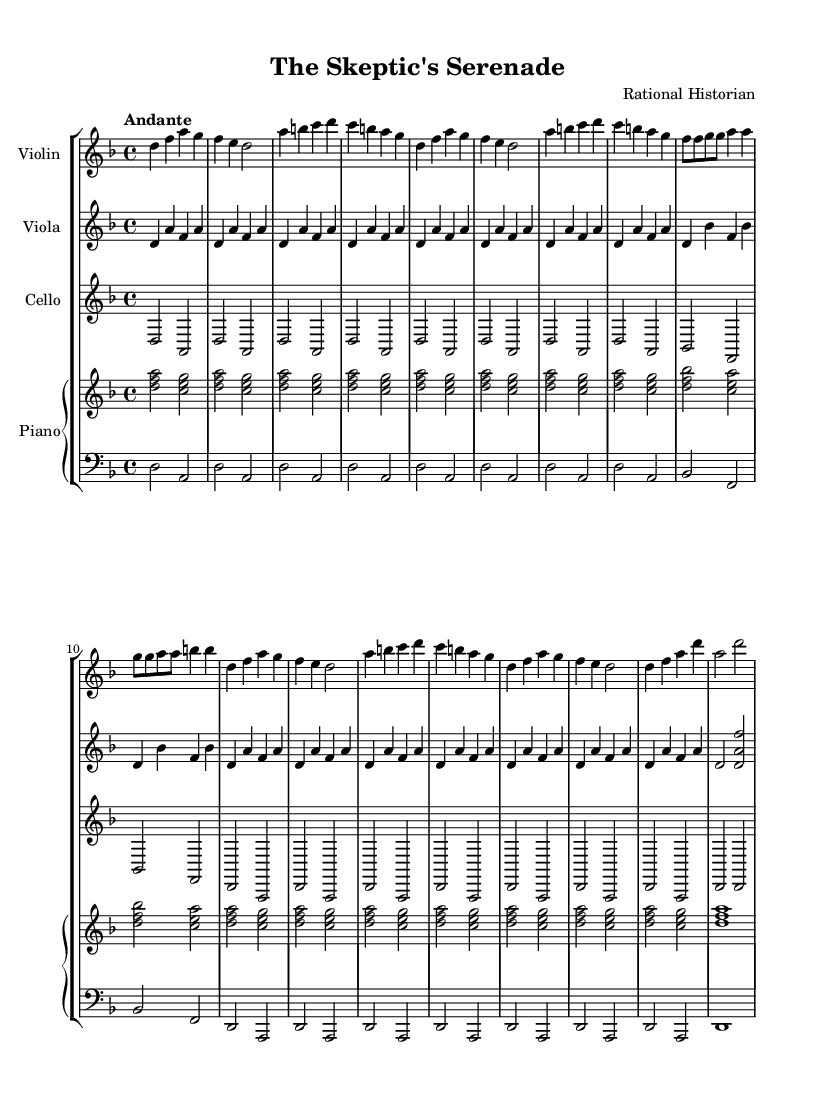What is the key signature of this music? The key signature is D minor, which has one flat (B flat). This can be identified near the beginning of the sheet music where the key signature is shown.
Answer: D minor What is the time signature of this piece? The time signature is 4/4, indicating that there are four quarter note beats in each measure. This is typically located at the start of the sheet music.
Answer: 4/4 What tempo marking is indicated for this composition? The tempo marking provided is "Andante," suggesting a moderate walking pace. This can be seen at the beginning of the sheet music.
Answer: Andante How many sections are represented in the music? The sheet music indicates at least five distinct sections: Introduction, Theme A, Theme B, Development, Recapitulation, and Coda. By analyzing the structure outlined in the music, one can identify each section's distinct character.
Answer: Six Which instrument has the highest pitch range in this piece? The violin, which usually plays the highest notes in a chamber music ensemble, is specifically noted to have the highest pitch range in this score. By observing the clefs and notes throughout the sheet music, it shows the violin's range exceeds that of the viola and cello.
Answer: Violin What is the relationship between Themes A and B in this work? Theme A reoccurs in a shortened form throughout the piece, while Theme B, also shortened, presents a contrasting idea. The contrast and recurrence of these themes create a structural framework common in classical compositions. The music shows how these themes interact through the development and recapitulation phases.
Answer: Contrast 